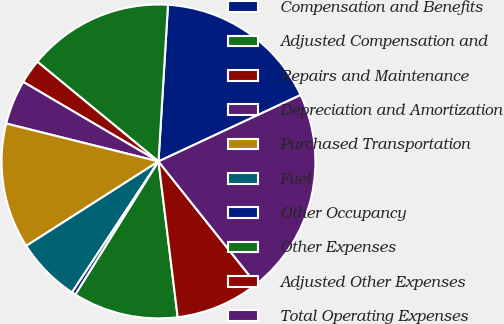Convert chart. <chart><loc_0><loc_0><loc_500><loc_500><pie_chart><fcel>Compensation and Benefits<fcel>Adjusted Compensation and<fcel>Repairs and Maintenance<fcel>Depreciation and Amortization<fcel>Purchased Transportation<fcel>Fuel<fcel>Other Occupancy<fcel>Other Expenses<fcel>Adjusted Other Expenses<fcel>Total Operating Expenses<nl><fcel>17.08%<fcel>15.0%<fcel>2.5%<fcel>4.58%<fcel>12.92%<fcel>6.67%<fcel>0.41%<fcel>10.83%<fcel>8.75%<fcel>21.25%<nl></chart> 